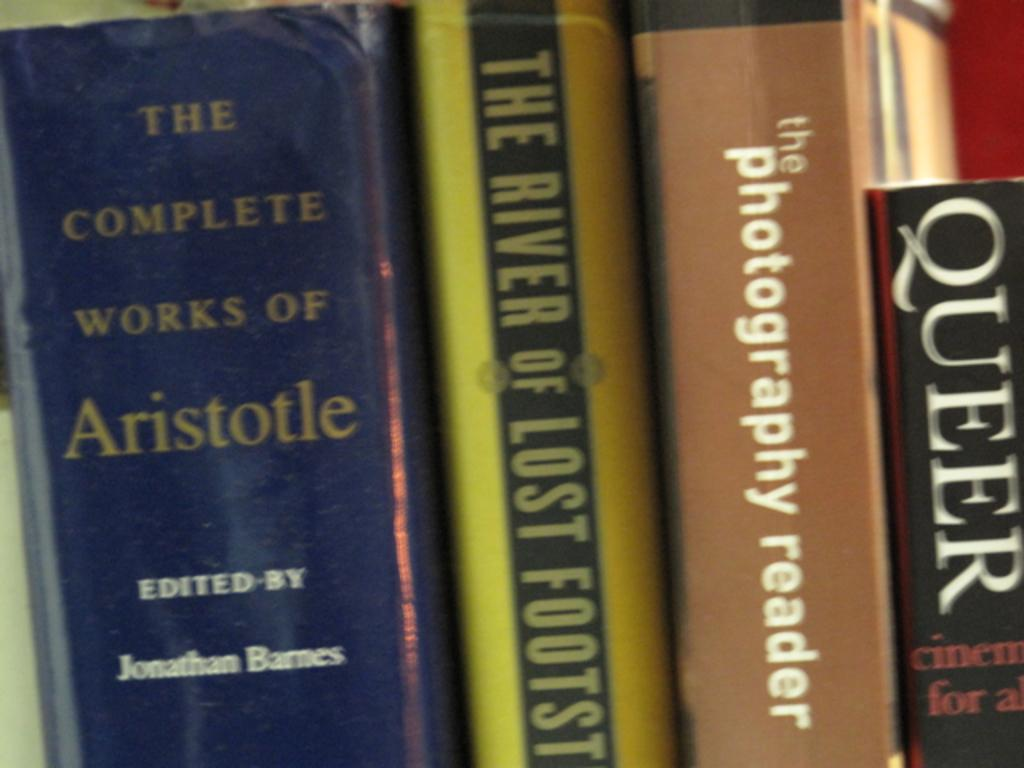<image>
Relay a brief, clear account of the picture shown. A book collection that includes the titles Queer and the Photography Reader. 